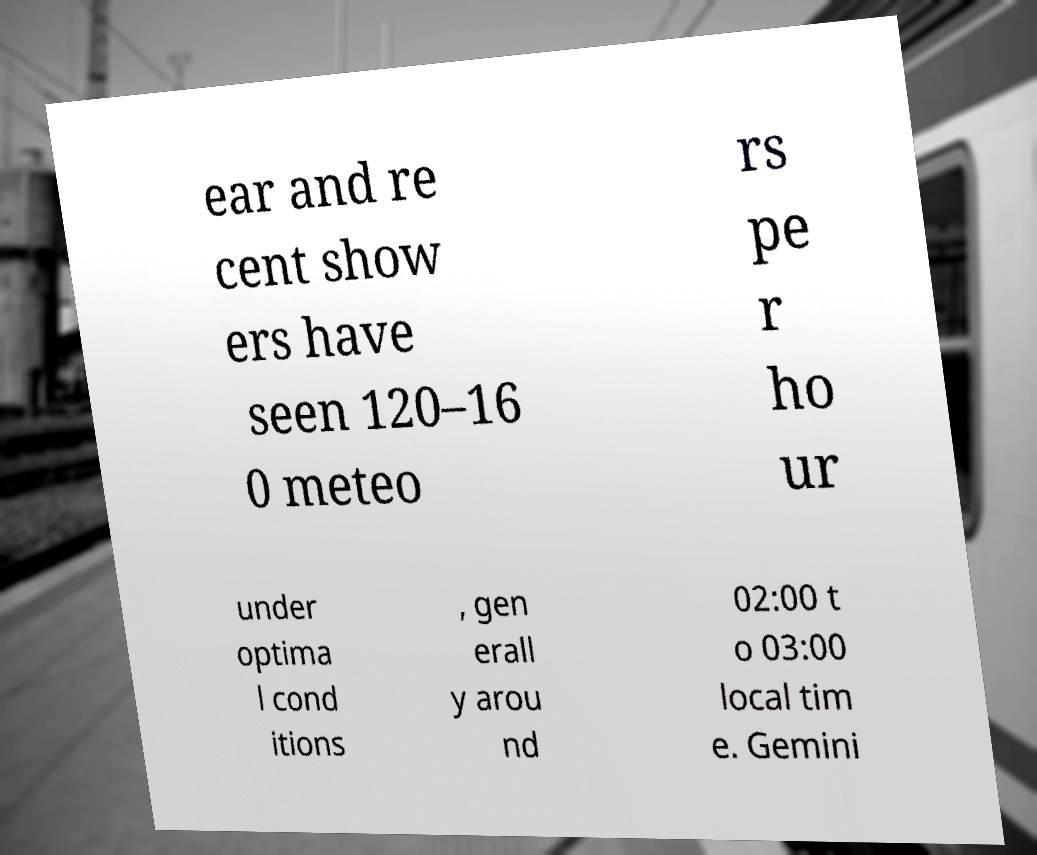Please read and relay the text visible in this image. What does it say? ear and re cent show ers have seen 120–16 0 meteo rs pe r ho ur under optima l cond itions , gen erall y arou nd 02:00 t o 03:00 local tim e. Gemini 